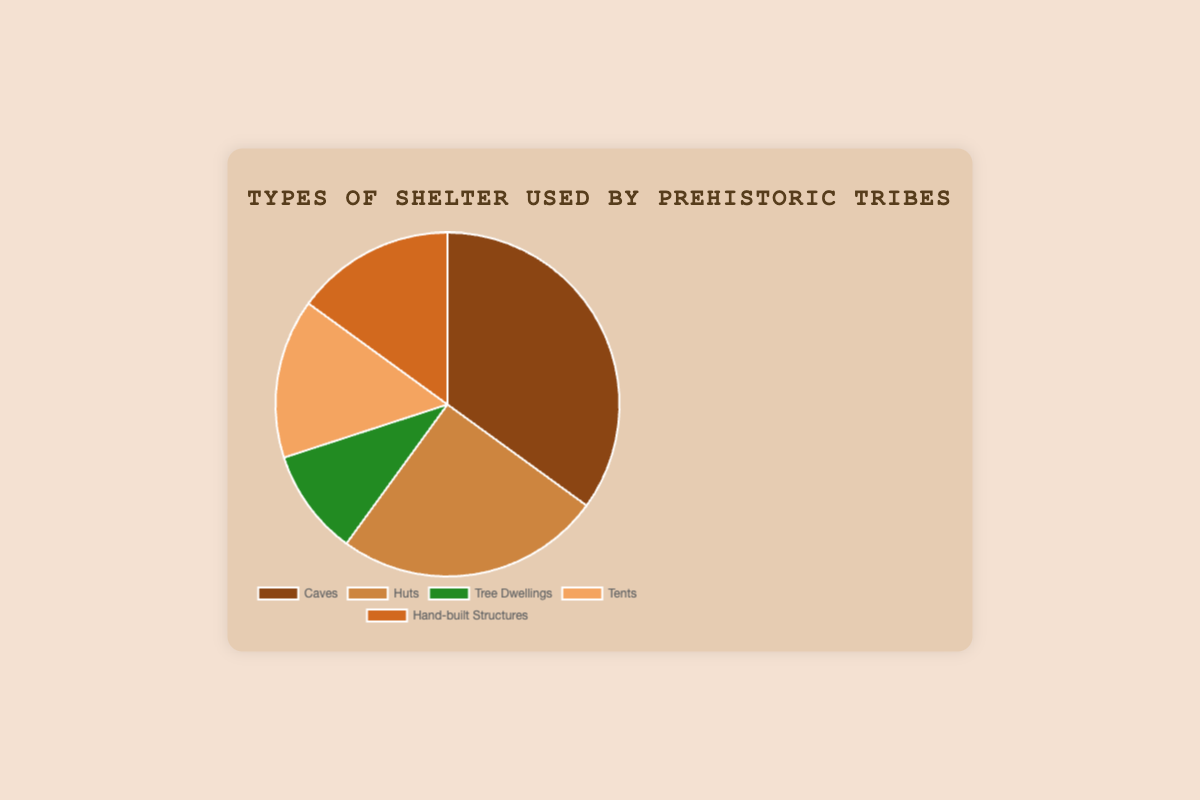what is the percentage of the least used shelter type? The least used shelter type is Tree Dwellings with a usage percentage of 10%. This can be easily seen from the pie chart by looking at the smallest segment.
Answer: 10% What is the combined usage percentage of Huts and Tents? According to the pie chart, Huts have a usage of 25% and Tents have a usage of 15%. Adding these together, the combined usage percentage is 25% + 15% = 40%.
Answer: 40% Which shelter type is used more: Hand-built Structures or Tree Dwellings? By comparing the sizes of the corresponding segments in the pie chart, we can see that Hand-built Structures (15%) are used more than Tree Dwellings (10%).
Answer: Hand-built Structures What is the color associated with the Huts segment? By referring to the color coding in the pie chart, the segment representing Huts is colored brown.
Answer: brown How much more common are Caves compared to Tree Dwellings? The chart shows that Caves are used 35% of the time and Tree Dwellings are used 10% of the time. The difference is 35% - 10% = 25%. Therefore, Caves are 25% more common than Tree Dwellings.
Answer: 25% What is the average usage percentage of Tents and Hand-built Structures? Tents have a usage percentage of 15% and Hand-built Structures also have a usage percentage of 15%. The average is calculated as (15% + 15%)/2 = 15%.
Answer: 15% Which two shelter types have equal usage percentages? The pie chart indicates that both Tents and Hand-built Structures have an equal usage percentage of 15%.
Answer: Tents and Hand-built Structures What is the median usage percentage of all shelter types? The percentages are 10% (Tree Dwellings), 15% (Tents), 15% (Hand-built Structures), 25% (Huts), and 35% (Caves). Arranging them in order, the median value (the middle one) is 15%.
Answer: 15% What is the total percentage of shelters involving animal materials (Huts and Tents)? Huts have a 25% usage and Tents have a 15% usage. Adding them, we get 25% + 15% = 40%. This total represents the shelters involving animal materials.
Answer: 40% 